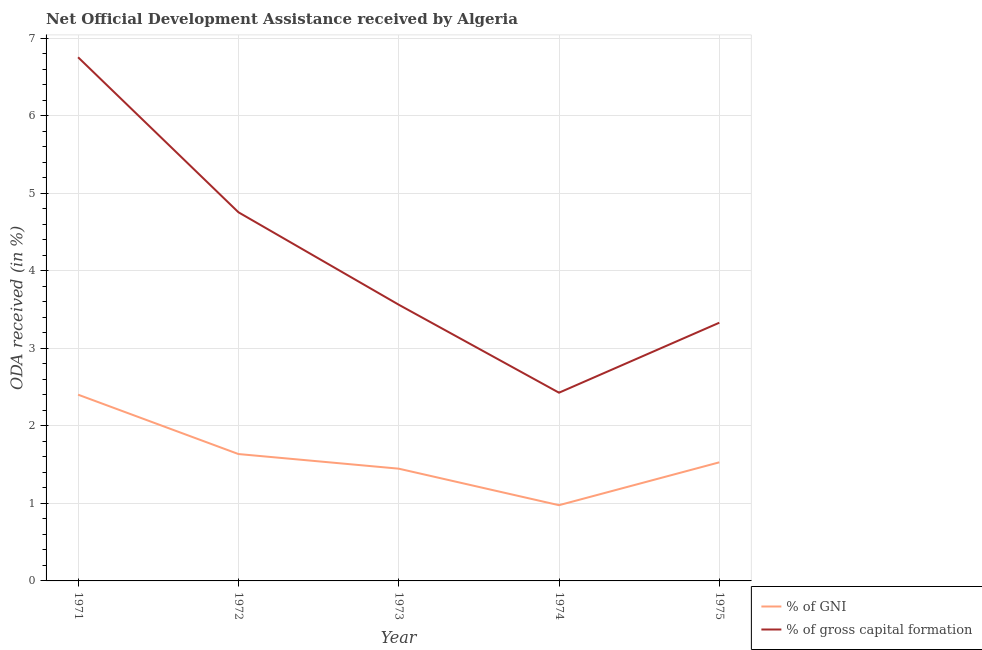Is the number of lines equal to the number of legend labels?
Keep it short and to the point. Yes. What is the oda received as percentage of gross capital formation in 1973?
Provide a succinct answer. 3.56. Across all years, what is the maximum oda received as percentage of gross capital formation?
Provide a succinct answer. 6.75. Across all years, what is the minimum oda received as percentage of gross capital formation?
Make the answer very short. 2.43. In which year was the oda received as percentage of gross capital formation maximum?
Give a very brief answer. 1971. In which year was the oda received as percentage of gross capital formation minimum?
Your answer should be compact. 1974. What is the total oda received as percentage of gni in the graph?
Your answer should be compact. 7.99. What is the difference between the oda received as percentage of gross capital formation in 1973 and that in 1974?
Provide a succinct answer. 1.14. What is the difference between the oda received as percentage of gni in 1974 and the oda received as percentage of gross capital formation in 1975?
Offer a very short reply. -2.35. What is the average oda received as percentage of gni per year?
Offer a terse response. 1.6. In the year 1972, what is the difference between the oda received as percentage of gni and oda received as percentage of gross capital formation?
Make the answer very short. -3.12. What is the ratio of the oda received as percentage of gross capital formation in 1974 to that in 1975?
Ensure brevity in your answer.  0.73. Is the oda received as percentage of gni in 1973 less than that in 1974?
Keep it short and to the point. No. Is the difference between the oda received as percentage of gni in 1973 and 1975 greater than the difference between the oda received as percentage of gross capital formation in 1973 and 1975?
Your answer should be compact. No. What is the difference between the highest and the second highest oda received as percentage of gross capital formation?
Keep it short and to the point. 2. What is the difference between the highest and the lowest oda received as percentage of gni?
Offer a very short reply. 1.43. In how many years, is the oda received as percentage of gni greater than the average oda received as percentage of gni taken over all years?
Provide a short and direct response. 2. Is the sum of the oda received as percentage of gni in 1973 and 1974 greater than the maximum oda received as percentage of gross capital formation across all years?
Provide a short and direct response. No. Is the oda received as percentage of gross capital formation strictly greater than the oda received as percentage of gni over the years?
Make the answer very short. Yes. How many years are there in the graph?
Keep it short and to the point. 5. Does the graph contain grids?
Your response must be concise. Yes. How are the legend labels stacked?
Your answer should be compact. Vertical. What is the title of the graph?
Keep it short and to the point. Net Official Development Assistance received by Algeria. Does "Urban agglomerations" appear as one of the legend labels in the graph?
Make the answer very short. No. What is the label or title of the X-axis?
Offer a terse response. Year. What is the label or title of the Y-axis?
Your answer should be very brief. ODA received (in %). What is the ODA received (in %) in % of GNI in 1971?
Make the answer very short. 2.4. What is the ODA received (in %) of % of gross capital formation in 1971?
Offer a terse response. 6.75. What is the ODA received (in %) in % of GNI in 1972?
Provide a succinct answer. 1.64. What is the ODA received (in %) in % of gross capital formation in 1972?
Your answer should be very brief. 4.76. What is the ODA received (in %) in % of GNI in 1973?
Your answer should be compact. 1.45. What is the ODA received (in %) of % of gross capital formation in 1973?
Your response must be concise. 3.56. What is the ODA received (in %) in % of GNI in 1974?
Make the answer very short. 0.98. What is the ODA received (in %) in % of gross capital formation in 1974?
Ensure brevity in your answer.  2.43. What is the ODA received (in %) of % of GNI in 1975?
Provide a succinct answer. 1.53. What is the ODA received (in %) in % of gross capital formation in 1975?
Ensure brevity in your answer.  3.33. Across all years, what is the maximum ODA received (in %) of % of GNI?
Your answer should be very brief. 2.4. Across all years, what is the maximum ODA received (in %) in % of gross capital formation?
Offer a very short reply. 6.75. Across all years, what is the minimum ODA received (in %) of % of GNI?
Keep it short and to the point. 0.98. Across all years, what is the minimum ODA received (in %) of % of gross capital formation?
Your response must be concise. 2.43. What is the total ODA received (in %) of % of GNI in the graph?
Provide a succinct answer. 7.99. What is the total ODA received (in %) of % of gross capital formation in the graph?
Offer a very short reply. 20.83. What is the difference between the ODA received (in %) in % of GNI in 1971 and that in 1972?
Provide a short and direct response. 0.77. What is the difference between the ODA received (in %) in % of gross capital formation in 1971 and that in 1972?
Offer a terse response. 2. What is the difference between the ODA received (in %) of % of GNI in 1971 and that in 1973?
Keep it short and to the point. 0.95. What is the difference between the ODA received (in %) in % of gross capital formation in 1971 and that in 1973?
Your answer should be very brief. 3.19. What is the difference between the ODA received (in %) in % of GNI in 1971 and that in 1974?
Provide a short and direct response. 1.43. What is the difference between the ODA received (in %) of % of gross capital formation in 1971 and that in 1974?
Your answer should be very brief. 4.33. What is the difference between the ODA received (in %) of % of GNI in 1971 and that in 1975?
Keep it short and to the point. 0.87. What is the difference between the ODA received (in %) in % of gross capital formation in 1971 and that in 1975?
Give a very brief answer. 3.42. What is the difference between the ODA received (in %) in % of GNI in 1972 and that in 1973?
Ensure brevity in your answer.  0.19. What is the difference between the ODA received (in %) in % of gross capital formation in 1972 and that in 1973?
Provide a succinct answer. 1.19. What is the difference between the ODA received (in %) in % of GNI in 1972 and that in 1974?
Provide a short and direct response. 0.66. What is the difference between the ODA received (in %) of % of gross capital formation in 1972 and that in 1974?
Offer a terse response. 2.33. What is the difference between the ODA received (in %) of % of GNI in 1972 and that in 1975?
Ensure brevity in your answer.  0.11. What is the difference between the ODA received (in %) of % of gross capital formation in 1972 and that in 1975?
Keep it short and to the point. 1.43. What is the difference between the ODA received (in %) in % of GNI in 1973 and that in 1974?
Make the answer very short. 0.47. What is the difference between the ODA received (in %) in % of gross capital formation in 1973 and that in 1974?
Give a very brief answer. 1.14. What is the difference between the ODA received (in %) of % of GNI in 1973 and that in 1975?
Ensure brevity in your answer.  -0.08. What is the difference between the ODA received (in %) in % of gross capital formation in 1973 and that in 1975?
Ensure brevity in your answer.  0.23. What is the difference between the ODA received (in %) of % of GNI in 1974 and that in 1975?
Your answer should be very brief. -0.55. What is the difference between the ODA received (in %) in % of gross capital formation in 1974 and that in 1975?
Provide a short and direct response. -0.9. What is the difference between the ODA received (in %) of % of GNI in 1971 and the ODA received (in %) of % of gross capital formation in 1972?
Make the answer very short. -2.35. What is the difference between the ODA received (in %) of % of GNI in 1971 and the ODA received (in %) of % of gross capital formation in 1973?
Offer a very short reply. -1.16. What is the difference between the ODA received (in %) in % of GNI in 1971 and the ODA received (in %) in % of gross capital formation in 1974?
Give a very brief answer. -0.03. What is the difference between the ODA received (in %) of % of GNI in 1971 and the ODA received (in %) of % of gross capital formation in 1975?
Offer a very short reply. -0.93. What is the difference between the ODA received (in %) of % of GNI in 1972 and the ODA received (in %) of % of gross capital formation in 1973?
Your answer should be compact. -1.93. What is the difference between the ODA received (in %) of % of GNI in 1972 and the ODA received (in %) of % of gross capital formation in 1974?
Offer a very short reply. -0.79. What is the difference between the ODA received (in %) in % of GNI in 1972 and the ODA received (in %) in % of gross capital formation in 1975?
Give a very brief answer. -1.69. What is the difference between the ODA received (in %) of % of GNI in 1973 and the ODA received (in %) of % of gross capital formation in 1974?
Your answer should be compact. -0.98. What is the difference between the ODA received (in %) of % of GNI in 1973 and the ODA received (in %) of % of gross capital formation in 1975?
Your answer should be compact. -1.88. What is the difference between the ODA received (in %) in % of GNI in 1974 and the ODA received (in %) in % of gross capital formation in 1975?
Offer a terse response. -2.35. What is the average ODA received (in %) of % of GNI per year?
Offer a terse response. 1.6. What is the average ODA received (in %) in % of gross capital formation per year?
Make the answer very short. 4.17. In the year 1971, what is the difference between the ODA received (in %) in % of GNI and ODA received (in %) in % of gross capital formation?
Your response must be concise. -4.35. In the year 1972, what is the difference between the ODA received (in %) of % of GNI and ODA received (in %) of % of gross capital formation?
Provide a short and direct response. -3.12. In the year 1973, what is the difference between the ODA received (in %) in % of GNI and ODA received (in %) in % of gross capital formation?
Make the answer very short. -2.12. In the year 1974, what is the difference between the ODA received (in %) in % of GNI and ODA received (in %) in % of gross capital formation?
Keep it short and to the point. -1.45. In the year 1975, what is the difference between the ODA received (in %) of % of GNI and ODA received (in %) of % of gross capital formation?
Your answer should be compact. -1.8. What is the ratio of the ODA received (in %) of % of GNI in 1971 to that in 1972?
Make the answer very short. 1.47. What is the ratio of the ODA received (in %) in % of gross capital formation in 1971 to that in 1972?
Give a very brief answer. 1.42. What is the ratio of the ODA received (in %) of % of GNI in 1971 to that in 1973?
Your answer should be compact. 1.66. What is the ratio of the ODA received (in %) of % of gross capital formation in 1971 to that in 1973?
Keep it short and to the point. 1.9. What is the ratio of the ODA received (in %) in % of GNI in 1971 to that in 1974?
Give a very brief answer. 2.46. What is the ratio of the ODA received (in %) of % of gross capital formation in 1971 to that in 1974?
Offer a terse response. 2.78. What is the ratio of the ODA received (in %) of % of GNI in 1971 to that in 1975?
Your answer should be very brief. 1.57. What is the ratio of the ODA received (in %) of % of gross capital formation in 1971 to that in 1975?
Offer a very short reply. 2.03. What is the ratio of the ODA received (in %) in % of GNI in 1972 to that in 1973?
Keep it short and to the point. 1.13. What is the ratio of the ODA received (in %) of % of gross capital formation in 1972 to that in 1973?
Your answer should be compact. 1.33. What is the ratio of the ODA received (in %) in % of GNI in 1972 to that in 1974?
Ensure brevity in your answer.  1.68. What is the ratio of the ODA received (in %) in % of gross capital formation in 1972 to that in 1974?
Your answer should be compact. 1.96. What is the ratio of the ODA received (in %) in % of GNI in 1972 to that in 1975?
Ensure brevity in your answer.  1.07. What is the ratio of the ODA received (in %) in % of gross capital formation in 1972 to that in 1975?
Make the answer very short. 1.43. What is the ratio of the ODA received (in %) in % of GNI in 1973 to that in 1974?
Give a very brief answer. 1.48. What is the ratio of the ODA received (in %) of % of gross capital formation in 1973 to that in 1974?
Your answer should be compact. 1.47. What is the ratio of the ODA received (in %) in % of GNI in 1973 to that in 1975?
Ensure brevity in your answer.  0.95. What is the ratio of the ODA received (in %) of % of gross capital formation in 1973 to that in 1975?
Your answer should be very brief. 1.07. What is the ratio of the ODA received (in %) of % of GNI in 1974 to that in 1975?
Make the answer very short. 0.64. What is the ratio of the ODA received (in %) of % of gross capital formation in 1974 to that in 1975?
Your answer should be very brief. 0.73. What is the difference between the highest and the second highest ODA received (in %) of % of GNI?
Make the answer very short. 0.77. What is the difference between the highest and the second highest ODA received (in %) in % of gross capital formation?
Ensure brevity in your answer.  2. What is the difference between the highest and the lowest ODA received (in %) of % of GNI?
Make the answer very short. 1.43. What is the difference between the highest and the lowest ODA received (in %) in % of gross capital formation?
Ensure brevity in your answer.  4.33. 